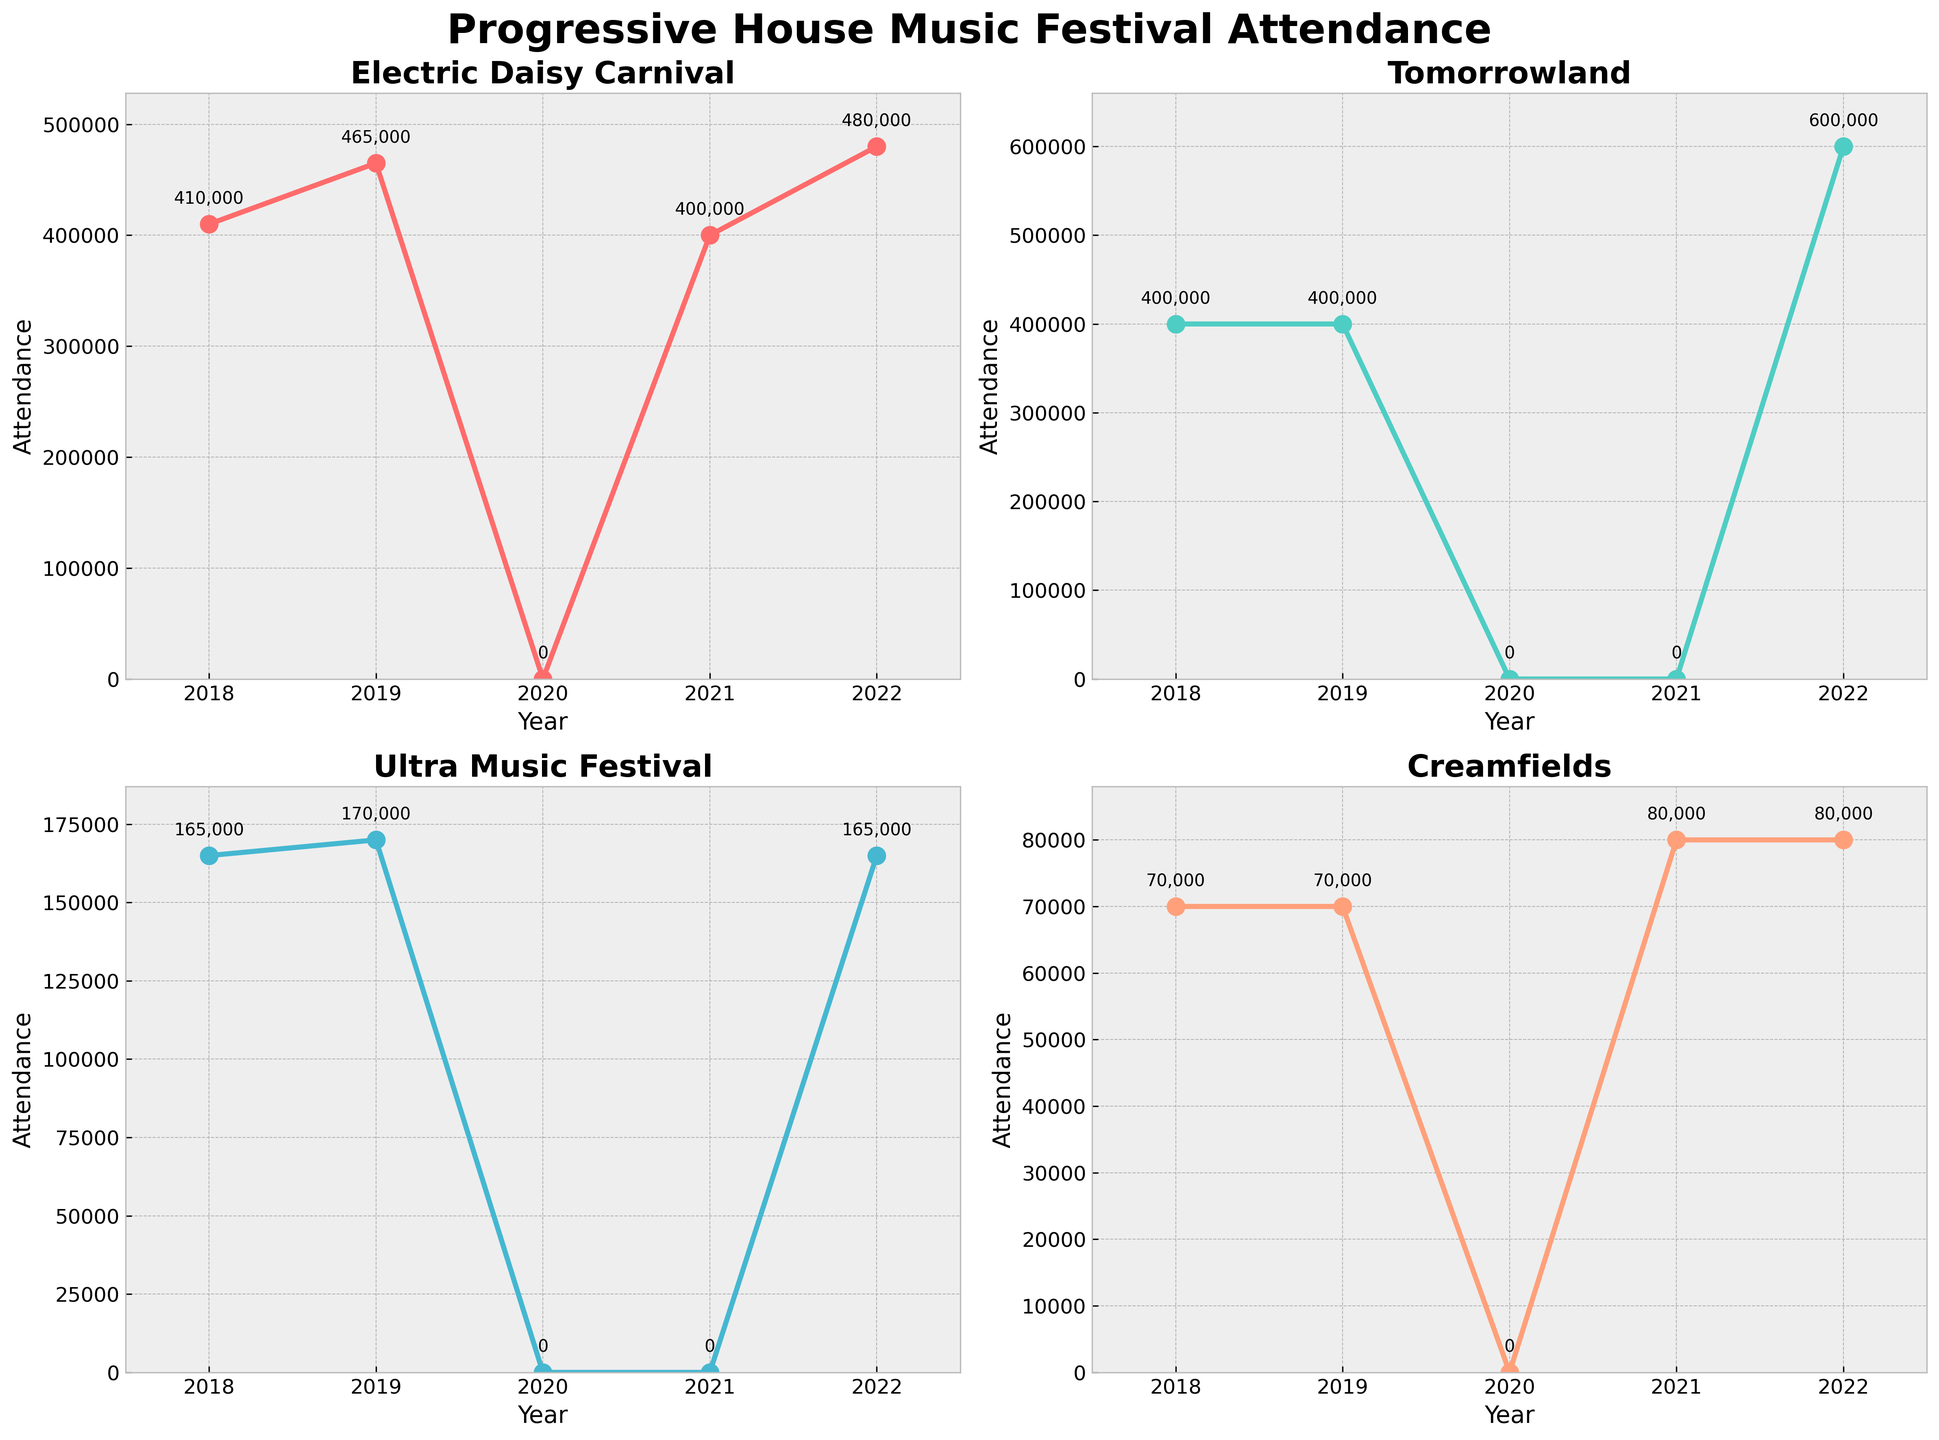Which festival had the highest attendance in 2022? By looking at the subplots for each festival, identify the highest attendance value in 2022. Electric Daisy Carnival had an attendance of 480,000, Tomorrowland had 600,000, Ultra Music Festival had 165,000, and Creamfields had 80,000. Among these values, Tomorrowland had the highest attendance.
Answer: Tomorrowland Which years did Tomorrowland not hold the festival? By examining the subplot for Tomorrowland, check for the years with an attendance of 0. The years with no attendance for Tomorrowland are 2020 and 2021.
Answer: 2020 and 2021 What is the general trend of attendance for Electric Daisy Carnival from 2018 to 2022? Analyze the attendance values in the subplot for Electric Daisy Carnival: 410,000 (2018), 465,000 (2019), 0 (2020), 400,000 (2021), and 480,000 (2022). Despite the dip to 0 in 2020, there is an overall increasing trend.
Answer: Increasing How did the attendance of Creamfields compare to Ultra Music Festival in 2021? Look at the attendance values for 2021 in the subplots for Creamfields and Ultra Music Festival. Creamfields has an attendance of 80,000, whereas Ultra Music Festival has 0 (no event was held). Therefore, Creamfields had higher attendance.
Answer: Creamfields had higher attendance What is the difference in attendance between 2018 and 2022 for Tomorrowland? Identify the attendance values for Tomorrowland in 2018 (400,000) and 2022 (600,000). Subtract the 2018 attendance from the 2022 attendance: 600,000 - 400,000 = 200,000.
Answer: 200,000 Which festival experienced the largest decrease in attendance from 2019 to 2020? Compare the attendance values for 2019 and 2020 for each festival. All festivals had 0 attendance in 2020, but for the largest decrease, Electric Daisy Carnival went from 465,000 (2019) to 0 (2020), Tomorrowland from 400,000 to 0, Ultra Music Festival from 170,000 to 0, and Creamfields from 70,000 to 0. The largest numerical decrease was for Electric Daisy Carnival.
Answer: Electric Daisy Carnival What is the average attendance of Ultra Music Festival from 2018 to 2022? Calculate the average by summing attendance values (165,000 in 2018 + 170,000 in 2019 + 0 in 2020 + 0 in 2021 + 165,000 in 2022) and dividing by the number of years: (165,000 + 170,000 + 0 + 0 + 165,000) / 5 = 100,000.
Answer: 100,000 How does the attendance pattern of Creamfields from 2018-2022 compare to Tomorrowland? Examine the trends in both subplots. Creamfields had attendances of 70,000 (2018), 70,000 (2019), 0 (2020), 80,000 (2021), 80,000 (2022). Tomorrowland had 400,000 (2018), 400,000 (2019), 0 (2020, 2021), 600,000 (2022). Both had no events in 2020, but Creamfields gradually increased whereas Tomorrowland sharply increased in 2022.
Answer: Creamfields gradually increased, Tomorrowland sharply increased In which year did Electric Daisy Carnival have its lowest attendance after 2018? Identify the years after 2018 in the subplot for Electric Daisy Carnival with the lowest attendance. It is 2020 with an attendance of 0. Excluding 2020, the lowest is 2021 with 400,000.
Answer: 2021 